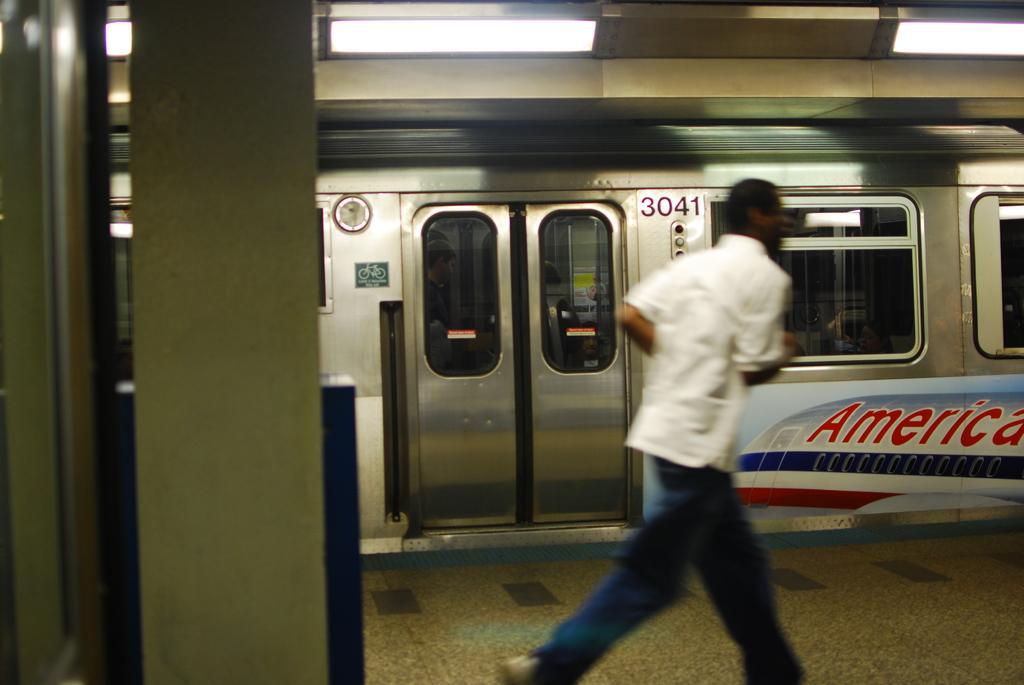In one or two sentences, can you explain what this image depicts? In the image there is a person in white shirt and blue jeans running on a platform and behind there is a train, there are lights over the ceiling. 